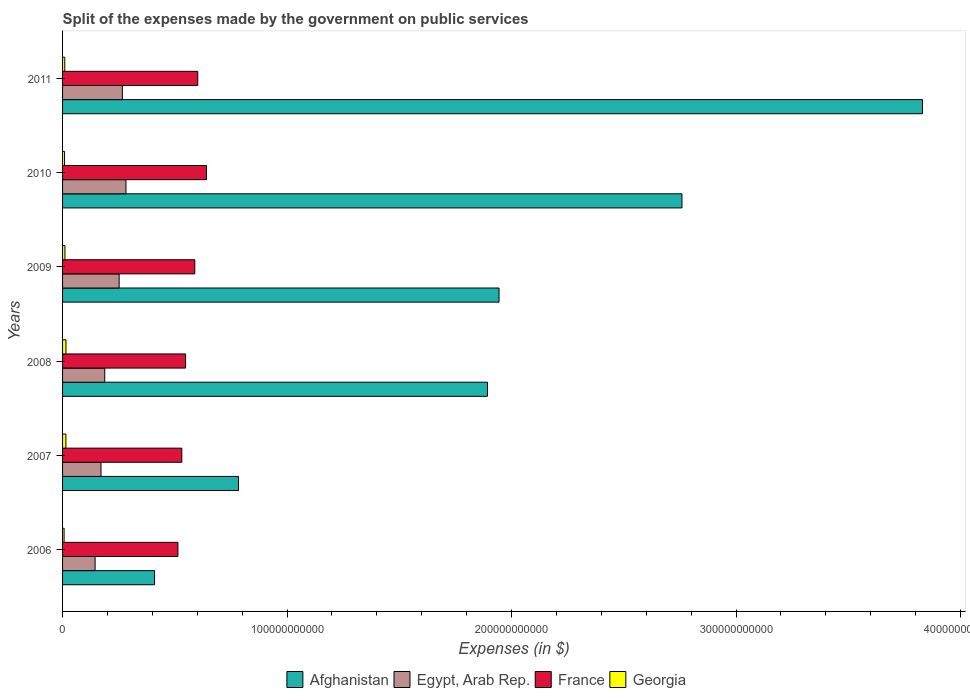What is the expenses made by the government on public services in Egypt, Arab Rep. in 2009?
Make the answer very short. 2.52e+1. Across all years, what is the maximum expenses made by the government on public services in Afghanistan?
Make the answer very short. 3.83e+11. Across all years, what is the minimum expenses made by the government on public services in France?
Make the answer very short. 5.14e+1. In which year was the expenses made by the government on public services in Egypt, Arab Rep. maximum?
Ensure brevity in your answer.  2010. In which year was the expenses made by the government on public services in Afghanistan minimum?
Offer a terse response. 2006. What is the total expenses made by the government on public services in Afghanistan in the graph?
Make the answer very short. 1.16e+12. What is the difference between the expenses made by the government on public services in Afghanistan in 2007 and that in 2011?
Your answer should be very brief. -3.05e+11. What is the difference between the expenses made by the government on public services in Afghanistan in 2010 and the expenses made by the government on public services in Georgia in 2009?
Ensure brevity in your answer.  2.75e+11. What is the average expenses made by the government on public services in Egypt, Arab Rep. per year?
Provide a succinct answer. 2.17e+1. In the year 2011, what is the difference between the expenses made by the government on public services in Afghanistan and expenses made by the government on public services in France?
Give a very brief answer. 3.23e+11. In how many years, is the expenses made by the government on public services in Afghanistan greater than 300000000000 $?
Provide a short and direct response. 1. What is the ratio of the expenses made by the government on public services in Egypt, Arab Rep. in 2009 to that in 2011?
Give a very brief answer. 0.95. Is the difference between the expenses made by the government on public services in Afghanistan in 2007 and 2010 greater than the difference between the expenses made by the government on public services in France in 2007 and 2010?
Offer a terse response. No. What is the difference between the highest and the second highest expenses made by the government on public services in Georgia?
Provide a short and direct response. 2.49e+07. What is the difference between the highest and the lowest expenses made by the government on public services in Georgia?
Keep it short and to the point. 8.30e+08. Is the sum of the expenses made by the government on public services in Egypt, Arab Rep. in 2007 and 2011 greater than the maximum expenses made by the government on public services in France across all years?
Ensure brevity in your answer.  No. Is it the case that in every year, the sum of the expenses made by the government on public services in Georgia and expenses made by the government on public services in France is greater than the sum of expenses made by the government on public services in Afghanistan and expenses made by the government on public services in Egypt, Arab Rep.?
Give a very brief answer. No. What does the 3rd bar from the top in 2009 represents?
Keep it short and to the point. Egypt, Arab Rep. What does the 1st bar from the bottom in 2007 represents?
Keep it short and to the point. Afghanistan. Is it the case that in every year, the sum of the expenses made by the government on public services in Georgia and expenses made by the government on public services in France is greater than the expenses made by the government on public services in Egypt, Arab Rep.?
Your response must be concise. Yes. How many bars are there?
Keep it short and to the point. 24. Are all the bars in the graph horizontal?
Keep it short and to the point. Yes. What is the difference between two consecutive major ticks on the X-axis?
Provide a succinct answer. 1.00e+11. Are the values on the major ticks of X-axis written in scientific E-notation?
Your answer should be very brief. No. Does the graph contain grids?
Provide a short and direct response. No. Where does the legend appear in the graph?
Provide a succinct answer. Bottom center. How many legend labels are there?
Provide a succinct answer. 4. How are the legend labels stacked?
Give a very brief answer. Horizontal. What is the title of the graph?
Offer a terse response. Split of the expenses made by the government on public services. Does "Yemen, Rep." appear as one of the legend labels in the graph?
Offer a terse response. No. What is the label or title of the X-axis?
Offer a very short reply. Expenses (in $). What is the Expenses (in $) of Afghanistan in 2006?
Provide a succinct answer. 4.10e+1. What is the Expenses (in $) of Egypt, Arab Rep. in 2006?
Ensure brevity in your answer.  1.45e+1. What is the Expenses (in $) of France in 2006?
Keep it short and to the point. 5.14e+1. What is the Expenses (in $) of Georgia in 2006?
Give a very brief answer. 6.78e+08. What is the Expenses (in $) in Afghanistan in 2007?
Make the answer very short. 7.84e+1. What is the Expenses (in $) in Egypt, Arab Rep. in 2007?
Your response must be concise. 1.71e+1. What is the Expenses (in $) in France in 2007?
Provide a succinct answer. 5.31e+1. What is the Expenses (in $) of Georgia in 2007?
Keep it short and to the point. 1.48e+09. What is the Expenses (in $) in Afghanistan in 2008?
Give a very brief answer. 1.89e+11. What is the Expenses (in $) of Egypt, Arab Rep. in 2008?
Provide a short and direct response. 1.88e+1. What is the Expenses (in $) in France in 2008?
Make the answer very short. 5.48e+1. What is the Expenses (in $) of Georgia in 2008?
Give a very brief answer. 1.51e+09. What is the Expenses (in $) of Afghanistan in 2009?
Offer a terse response. 1.94e+11. What is the Expenses (in $) of Egypt, Arab Rep. in 2009?
Your answer should be very brief. 2.52e+1. What is the Expenses (in $) in France in 2009?
Provide a succinct answer. 5.89e+1. What is the Expenses (in $) in Georgia in 2009?
Make the answer very short. 1.06e+09. What is the Expenses (in $) in Afghanistan in 2010?
Give a very brief answer. 2.76e+11. What is the Expenses (in $) of Egypt, Arab Rep. in 2010?
Make the answer very short. 2.82e+1. What is the Expenses (in $) in France in 2010?
Offer a very short reply. 6.41e+1. What is the Expenses (in $) of Georgia in 2010?
Your response must be concise. 8.82e+08. What is the Expenses (in $) of Afghanistan in 2011?
Your response must be concise. 3.83e+11. What is the Expenses (in $) of Egypt, Arab Rep. in 2011?
Your answer should be compact. 2.66e+1. What is the Expenses (in $) in France in 2011?
Keep it short and to the point. 6.02e+1. What is the Expenses (in $) in Georgia in 2011?
Provide a succinct answer. 9.89e+08. Across all years, what is the maximum Expenses (in $) of Afghanistan?
Your response must be concise. 3.83e+11. Across all years, what is the maximum Expenses (in $) in Egypt, Arab Rep.?
Your answer should be compact. 2.82e+1. Across all years, what is the maximum Expenses (in $) of France?
Provide a succinct answer. 6.41e+1. Across all years, what is the maximum Expenses (in $) of Georgia?
Provide a succinct answer. 1.51e+09. Across all years, what is the minimum Expenses (in $) of Afghanistan?
Provide a short and direct response. 4.10e+1. Across all years, what is the minimum Expenses (in $) of Egypt, Arab Rep.?
Your answer should be compact. 1.45e+1. Across all years, what is the minimum Expenses (in $) in France?
Your answer should be very brief. 5.14e+1. Across all years, what is the minimum Expenses (in $) in Georgia?
Your response must be concise. 6.78e+08. What is the total Expenses (in $) of Afghanistan in the graph?
Keep it short and to the point. 1.16e+12. What is the total Expenses (in $) in Egypt, Arab Rep. in the graph?
Your response must be concise. 1.30e+11. What is the total Expenses (in $) of France in the graph?
Keep it short and to the point. 3.43e+11. What is the total Expenses (in $) of Georgia in the graph?
Your answer should be compact. 6.60e+09. What is the difference between the Expenses (in $) of Afghanistan in 2006 and that in 2007?
Give a very brief answer. -3.74e+1. What is the difference between the Expenses (in $) of Egypt, Arab Rep. in 2006 and that in 2007?
Make the answer very short. -2.63e+09. What is the difference between the Expenses (in $) in France in 2006 and that in 2007?
Provide a short and direct response. -1.73e+09. What is the difference between the Expenses (in $) of Georgia in 2006 and that in 2007?
Offer a terse response. -8.05e+08. What is the difference between the Expenses (in $) of Afghanistan in 2006 and that in 2008?
Your answer should be compact. -1.48e+11. What is the difference between the Expenses (in $) in Egypt, Arab Rep. in 2006 and that in 2008?
Offer a very short reply. -4.30e+09. What is the difference between the Expenses (in $) in France in 2006 and that in 2008?
Offer a terse response. -3.41e+09. What is the difference between the Expenses (in $) in Georgia in 2006 and that in 2008?
Ensure brevity in your answer.  -8.30e+08. What is the difference between the Expenses (in $) of Afghanistan in 2006 and that in 2009?
Provide a short and direct response. -1.53e+11. What is the difference between the Expenses (in $) in Egypt, Arab Rep. in 2006 and that in 2009?
Provide a succinct answer. -1.07e+1. What is the difference between the Expenses (in $) of France in 2006 and that in 2009?
Offer a very short reply. -7.52e+09. What is the difference between the Expenses (in $) in Georgia in 2006 and that in 2009?
Provide a short and direct response. -3.77e+08. What is the difference between the Expenses (in $) of Afghanistan in 2006 and that in 2010?
Your response must be concise. -2.35e+11. What is the difference between the Expenses (in $) of Egypt, Arab Rep. in 2006 and that in 2010?
Provide a short and direct response. -1.38e+1. What is the difference between the Expenses (in $) of France in 2006 and that in 2010?
Offer a terse response. -1.27e+1. What is the difference between the Expenses (in $) in Georgia in 2006 and that in 2010?
Offer a terse response. -2.03e+08. What is the difference between the Expenses (in $) of Afghanistan in 2006 and that in 2011?
Provide a succinct answer. -3.42e+11. What is the difference between the Expenses (in $) in Egypt, Arab Rep. in 2006 and that in 2011?
Ensure brevity in your answer.  -1.22e+1. What is the difference between the Expenses (in $) in France in 2006 and that in 2011?
Your answer should be compact. -8.83e+09. What is the difference between the Expenses (in $) of Georgia in 2006 and that in 2011?
Offer a very short reply. -3.10e+08. What is the difference between the Expenses (in $) of Afghanistan in 2007 and that in 2008?
Your answer should be very brief. -1.11e+11. What is the difference between the Expenses (in $) in Egypt, Arab Rep. in 2007 and that in 2008?
Keep it short and to the point. -1.67e+09. What is the difference between the Expenses (in $) in France in 2007 and that in 2008?
Ensure brevity in your answer.  -1.68e+09. What is the difference between the Expenses (in $) of Georgia in 2007 and that in 2008?
Ensure brevity in your answer.  -2.49e+07. What is the difference between the Expenses (in $) of Afghanistan in 2007 and that in 2009?
Keep it short and to the point. -1.16e+11. What is the difference between the Expenses (in $) in Egypt, Arab Rep. in 2007 and that in 2009?
Make the answer very short. -8.08e+09. What is the difference between the Expenses (in $) in France in 2007 and that in 2009?
Make the answer very short. -5.79e+09. What is the difference between the Expenses (in $) of Georgia in 2007 and that in 2009?
Offer a terse response. 4.29e+08. What is the difference between the Expenses (in $) of Afghanistan in 2007 and that in 2010?
Make the answer very short. -1.98e+11. What is the difference between the Expenses (in $) of Egypt, Arab Rep. in 2007 and that in 2010?
Your answer should be very brief. -1.11e+1. What is the difference between the Expenses (in $) in France in 2007 and that in 2010?
Ensure brevity in your answer.  -1.10e+1. What is the difference between the Expenses (in $) of Georgia in 2007 and that in 2010?
Offer a very short reply. 6.02e+08. What is the difference between the Expenses (in $) in Afghanistan in 2007 and that in 2011?
Ensure brevity in your answer.  -3.05e+11. What is the difference between the Expenses (in $) in Egypt, Arab Rep. in 2007 and that in 2011?
Offer a very short reply. -9.52e+09. What is the difference between the Expenses (in $) of France in 2007 and that in 2011?
Provide a succinct answer. -7.10e+09. What is the difference between the Expenses (in $) of Georgia in 2007 and that in 2011?
Your response must be concise. 4.95e+08. What is the difference between the Expenses (in $) of Afghanistan in 2008 and that in 2009?
Provide a short and direct response. -5.15e+09. What is the difference between the Expenses (in $) of Egypt, Arab Rep. in 2008 and that in 2009?
Make the answer very short. -6.41e+09. What is the difference between the Expenses (in $) in France in 2008 and that in 2009?
Keep it short and to the point. -4.11e+09. What is the difference between the Expenses (in $) in Georgia in 2008 and that in 2009?
Provide a short and direct response. 4.54e+08. What is the difference between the Expenses (in $) of Afghanistan in 2008 and that in 2010?
Give a very brief answer. -8.66e+1. What is the difference between the Expenses (in $) in Egypt, Arab Rep. in 2008 and that in 2010?
Ensure brevity in your answer.  -9.46e+09. What is the difference between the Expenses (in $) in France in 2008 and that in 2010?
Offer a very short reply. -9.30e+09. What is the difference between the Expenses (in $) in Georgia in 2008 and that in 2010?
Ensure brevity in your answer.  6.27e+08. What is the difference between the Expenses (in $) of Afghanistan in 2008 and that in 2011?
Give a very brief answer. -1.94e+11. What is the difference between the Expenses (in $) in Egypt, Arab Rep. in 2008 and that in 2011?
Offer a very short reply. -7.86e+09. What is the difference between the Expenses (in $) in France in 2008 and that in 2011?
Your answer should be compact. -5.42e+09. What is the difference between the Expenses (in $) of Georgia in 2008 and that in 2011?
Keep it short and to the point. 5.20e+08. What is the difference between the Expenses (in $) in Afghanistan in 2009 and that in 2010?
Offer a very short reply. -8.15e+1. What is the difference between the Expenses (in $) of Egypt, Arab Rep. in 2009 and that in 2010?
Provide a succinct answer. -3.04e+09. What is the difference between the Expenses (in $) in France in 2009 and that in 2010?
Provide a short and direct response. -5.20e+09. What is the difference between the Expenses (in $) in Georgia in 2009 and that in 2010?
Your response must be concise. 1.74e+08. What is the difference between the Expenses (in $) in Afghanistan in 2009 and that in 2011?
Your response must be concise. -1.89e+11. What is the difference between the Expenses (in $) in Egypt, Arab Rep. in 2009 and that in 2011?
Give a very brief answer. -1.44e+09. What is the difference between the Expenses (in $) in France in 2009 and that in 2011?
Keep it short and to the point. -1.31e+09. What is the difference between the Expenses (in $) of Georgia in 2009 and that in 2011?
Provide a short and direct response. 6.62e+07. What is the difference between the Expenses (in $) in Afghanistan in 2010 and that in 2011?
Offer a terse response. -1.07e+11. What is the difference between the Expenses (in $) in Egypt, Arab Rep. in 2010 and that in 2011?
Make the answer very short. 1.60e+09. What is the difference between the Expenses (in $) of France in 2010 and that in 2011?
Give a very brief answer. 3.88e+09. What is the difference between the Expenses (in $) of Georgia in 2010 and that in 2011?
Offer a very short reply. -1.07e+08. What is the difference between the Expenses (in $) in Afghanistan in 2006 and the Expenses (in $) in Egypt, Arab Rep. in 2007?
Your answer should be very brief. 2.39e+1. What is the difference between the Expenses (in $) of Afghanistan in 2006 and the Expenses (in $) of France in 2007?
Offer a very short reply. -1.21e+1. What is the difference between the Expenses (in $) in Afghanistan in 2006 and the Expenses (in $) in Georgia in 2007?
Offer a terse response. 3.95e+1. What is the difference between the Expenses (in $) of Egypt, Arab Rep. in 2006 and the Expenses (in $) of France in 2007?
Make the answer very short. -3.86e+1. What is the difference between the Expenses (in $) of Egypt, Arab Rep. in 2006 and the Expenses (in $) of Georgia in 2007?
Ensure brevity in your answer.  1.30e+1. What is the difference between the Expenses (in $) in France in 2006 and the Expenses (in $) in Georgia in 2007?
Your response must be concise. 4.99e+1. What is the difference between the Expenses (in $) of Afghanistan in 2006 and the Expenses (in $) of Egypt, Arab Rep. in 2008?
Provide a short and direct response. 2.22e+1. What is the difference between the Expenses (in $) in Afghanistan in 2006 and the Expenses (in $) in France in 2008?
Make the answer very short. -1.38e+1. What is the difference between the Expenses (in $) in Afghanistan in 2006 and the Expenses (in $) in Georgia in 2008?
Ensure brevity in your answer.  3.95e+1. What is the difference between the Expenses (in $) in Egypt, Arab Rep. in 2006 and the Expenses (in $) in France in 2008?
Offer a terse response. -4.03e+1. What is the difference between the Expenses (in $) of Egypt, Arab Rep. in 2006 and the Expenses (in $) of Georgia in 2008?
Keep it short and to the point. 1.30e+1. What is the difference between the Expenses (in $) in France in 2006 and the Expenses (in $) in Georgia in 2008?
Your answer should be compact. 4.99e+1. What is the difference between the Expenses (in $) in Afghanistan in 2006 and the Expenses (in $) in Egypt, Arab Rep. in 2009?
Give a very brief answer. 1.58e+1. What is the difference between the Expenses (in $) of Afghanistan in 2006 and the Expenses (in $) of France in 2009?
Give a very brief answer. -1.79e+1. What is the difference between the Expenses (in $) in Afghanistan in 2006 and the Expenses (in $) in Georgia in 2009?
Provide a succinct answer. 3.99e+1. What is the difference between the Expenses (in $) of Egypt, Arab Rep. in 2006 and the Expenses (in $) of France in 2009?
Ensure brevity in your answer.  -4.44e+1. What is the difference between the Expenses (in $) in Egypt, Arab Rep. in 2006 and the Expenses (in $) in Georgia in 2009?
Your answer should be compact. 1.34e+1. What is the difference between the Expenses (in $) in France in 2006 and the Expenses (in $) in Georgia in 2009?
Provide a short and direct response. 5.03e+1. What is the difference between the Expenses (in $) in Afghanistan in 2006 and the Expenses (in $) in Egypt, Arab Rep. in 2010?
Keep it short and to the point. 1.27e+1. What is the difference between the Expenses (in $) of Afghanistan in 2006 and the Expenses (in $) of France in 2010?
Ensure brevity in your answer.  -2.31e+1. What is the difference between the Expenses (in $) in Afghanistan in 2006 and the Expenses (in $) in Georgia in 2010?
Make the answer very short. 4.01e+1. What is the difference between the Expenses (in $) of Egypt, Arab Rep. in 2006 and the Expenses (in $) of France in 2010?
Offer a very short reply. -4.96e+1. What is the difference between the Expenses (in $) of Egypt, Arab Rep. in 2006 and the Expenses (in $) of Georgia in 2010?
Offer a very short reply. 1.36e+1. What is the difference between the Expenses (in $) in France in 2006 and the Expenses (in $) in Georgia in 2010?
Give a very brief answer. 5.05e+1. What is the difference between the Expenses (in $) in Afghanistan in 2006 and the Expenses (in $) in Egypt, Arab Rep. in 2011?
Keep it short and to the point. 1.43e+1. What is the difference between the Expenses (in $) in Afghanistan in 2006 and the Expenses (in $) in France in 2011?
Provide a short and direct response. -1.92e+1. What is the difference between the Expenses (in $) in Afghanistan in 2006 and the Expenses (in $) in Georgia in 2011?
Provide a succinct answer. 4.00e+1. What is the difference between the Expenses (in $) in Egypt, Arab Rep. in 2006 and the Expenses (in $) in France in 2011?
Ensure brevity in your answer.  -4.57e+1. What is the difference between the Expenses (in $) of Egypt, Arab Rep. in 2006 and the Expenses (in $) of Georgia in 2011?
Your answer should be compact. 1.35e+1. What is the difference between the Expenses (in $) in France in 2006 and the Expenses (in $) in Georgia in 2011?
Provide a short and direct response. 5.04e+1. What is the difference between the Expenses (in $) of Afghanistan in 2007 and the Expenses (in $) of Egypt, Arab Rep. in 2008?
Make the answer very short. 5.96e+1. What is the difference between the Expenses (in $) in Afghanistan in 2007 and the Expenses (in $) in France in 2008?
Make the answer very short. 2.36e+1. What is the difference between the Expenses (in $) of Afghanistan in 2007 and the Expenses (in $) of Georgia in 2008?
Your answer should be very brief. 7.69e+1. What is the difference between the Expenses (in $) of Egypt, Arab Rep. in 2007 and the Expenses (in $) of France in 2008?
Your answer should be very brief. -3.77e+1. What is the difference between the Expenses (in $) in Egypt, Arab Rep. in 2007 and the Expenses (in $) in Georgia in 2008?
Ensure brevity in your answer.  1.56e+1. What is the difference between the Expenses (in $) of France in 2007 and the Expenses (in $) of Georgia in 2008?
Keep it short and to the point. 5.16e+1. What is the difference between the Expenses (in $) in Afghanistan in 2007 and the Expenses (in $) in Egypt, Arab Rep. in 2009?
Your answer should be very brief. 5.32e+1. What is the difference between the Expenses (in $) of Afghanistan in 2007 and the Expenses (in $) of France in 2009?
Offer a terse response. 1.95e+1. What is the difference between the Expenses (in $) in Afghanistan in 2007 and the Expenses (in $) in Georgia in 2009?
Make the answer very short. 7.73e+1. What is the difference between the Expenses (in $) of Egypt, Arab Rep. in 2007 and the Expenses (in $) of France in 2009?
Make the answer very short. -4.18e+1. What is the difference between the Expenses (in $) of Egypt, Arab Rep. in 2007 and the Expenses (in $) of Georgia in 2009?
Provide a short and direct response. 1.61e+1. What is the difference between the Expenses (in $) of France in 2007 and the Expenses (in $) of Georgia in 2009?
Ensure brevity in your answer.  5.21e+1. What is the difference between the Expenses (in $) of Afghanistan in 2007 and the Expenses (in $) of Egypt, Arab Rep. in 2010?
Offer a terse response. 5.01e+1. What is the difference between the Expenses (in $) in Afghanistan in 2007 and the Expenses (in $) in France in 2010?
Provide a short and direct response. 1.43e+1. What is the difference between the Expenses (in $) in Afghanistan in 2007 and the Expenses (in $) in Georgia in 2010?
Provide a succinct answer. 7.75e+1. What is the difference between the Expenses (in $) in Egypt, Arab Rep. in 2007 and the Expenses (in $) in France in 2010?
Give a very brief answer. -4.70e+1. What is the difference between the Expenses (in $) of Egypt, Arab Rep. in 2007 and the Expenses (in $) of Georgia in 2010?
Offer a terse response. 1.62e+1. What is the difference between the Expenses (in $) of France in 2007 and the Expenses (in $) of Georgia in 2010?
Your response must be concise. 5.22e+1. What is the difference between the Expenses (in $) in Afghanistan in 2007 and the Expenses (in $) in Egypt, Arab Rep. in 2011?
Your response must be concise. 5.17e+1. What is the difference between the Expenses (in $) of Afghanistan in 2007 and the Expenses (in $) of France in 2011?
Your answer should be compact. 1.81e+1. What is the difference between the Expenses (in $) of Afghanistan in 2007 and the Expenses (in $) of Georgia in 2011?
Your answer should be compact. 7.74e+1. What is the difference between the Expenses (in $) of Egypt, Arab Rep. in 2007 and the Expenses (in $) of France in 2011?
Your answer should be very brief. -4.31e+1. What is the difference between the Expenses (in $) of Egypt, Arab Rep. in 2007 and the Expenses (in $) of Georgia in 2011?
Give a very brief answer. 1.61e+1. What is the difference between the Expenses (in $) in France in 2007 and the Expenses (in $) in Georgia in 2011?
Your response must be concise. 5.21e+1. What is the difference between the Expenses (in $) in Afghanistan in 2008 and the Expenses (in $) in Egypt, Arab Rep. in 2009?
Offer a terse response. 1.64e+11. What is the difference between the Expenses (in $) of Afghanistan in 2008 and the Expenses (in $) of France in 2009?
Ensure brevity in your answer.  1.30e+11. What is the difference between the Expenses (in $) of Afghanistan in 2008 and the Expenses (in $) of Georgia in 2009?
Your response must be concise. 1.88e+11. What is the difference between the Expenses (in $) in Egypt, Arab Rep. in 2008 and the Expenses (in $) in France in 2009?
Offer a very short reply. -4.01e+1. What is the difference between the Expenses (in $) of Egypt, Arab Rep. in 2008 and the Expenses (in $) of Georgia in 2009?
Keep it short and to the point. 1.77e+1. What is the difference between the Expenses (in $) in France in 2008 and the Expenses (in $) in Georgia in 2009?
Provide a succinct answer. 5.37e+1. What is the difference between the Expenses (in $) in Afghanistan in 2008 and the Expenses (in $) in Egypt, Arab Rep. in 2010?
Make the answer very short. 1.61e+11. What is the difference between the Expenses (in $) in Afghanistan in 2008 and the Expenses (in $) in France in 2010?
Offer a terse response. 1.25e+11. What is the difference between the Expenses (in $) of Afghanistan in 2008 and the Expenses (in $) of Georgia in 2010?
Offer a terse response. 1.88e+11. What is the difference between the Expenses (in $) of Egypt, Arab Rep. in 2008 and the Expenses (in $) of France in 2010?
Your response must be concise. -4.53e+1. What is the difference between the Expenses (in $) of Egypt, Arab Rep. in 2008 and the Expenses (in $) of Georgia in 2010?
Keep it short and to the point. 1.79e+1. What is the difference between the Expenses (in $) of France in 2008 and the Expenses (in $) of Georgia in 2010?
Offer a terse response. 5.39e+1. What is the difference between the Expenses (in $) in Afghanistan in 2008 and the Expenses (in $) in Egypt, Arab Rep. in 2011?
Provide a short and direct response. 1.63e+11. What is the difference between the Expenses (in $) in Afghanistan in 2008 and the Expenses (in $) in France in 2011?
Your response must be concise. 1.29e+11. What is the difference between the Expenses (in $) in Afghanistan in 2008 and the Expenses (in $) in Georgia in 2011?
Make the answer very short. 1.88e+11. What is the difference between the Expenses (in $) in Egypt, Arab Rep. in 2008 and the Expenses (in $) in France in 2011?
Provide a succinct answer. -4.14e+1. What is the difference between the Expenses (in $) of Egypt, Arab Rep. in 2008 and the Expenses (in $) of Georgia in 2011?
Offer a very short reply. 1.78e+1. What is the difference between the Expenses (in $) of France in 2008 and the Expenses (in $) of Georgia in 2011?
Offer a terse response. 5.38e+1. What is the difference between the Expenses (in $) of Afghanistan in 2009 and the Expenses (in $) of Egypt, Arab Rep. in 2010?
Ensure brevity in your answer.  1.66e+11. What is the difference between the Expenses (in $) of Afghanistan in 2009 and the Expenses (in $) of France in 2010?
Keep it short and to the point. 1.30e+11. What is the difference between the Expenses (in $) of Afghanistan in 2009 and the Expenses (in $) of Georgia in 2010?
Offer a very short reply. 1.94e+11. What is the difference between the Expenses (in $) of Egypt, Arab Rep. in 2009 and the Expenses (in $) of France in 2010?
Your answer should be very brief. -3.89e+1. What is the difference between the Expenses (in $) of Egypt, Arab Rep. in 2009 and the Expenses (in $) of Georgia in 2010?
Your response must be concise. 2.43e+1. What is the difference between the Expenses (in $) of France in 2009 and the Expenses (in $) of Georgia in 2010?
Your response must be concise. 5.80e+1. What is the difference between the Expenses (in $) in Afghanistan in 2009 and the Expenses (in $) in Egypt, Arab Rep. in 2011?
Ensure brevity in your answer.  1.68e+11. What is the difference between the Expenses (in $) in Afghanistan in 2009 and the Expenses (in $) in France in 2011?
Keep it short and to the point. 1.34e+11. What is the difference between the Expenses (in $) of Afghanistan in 2009 and the Expenses (in $) of Georgia in 2011?
Provide a succinct answer. 1.93e+11. What is the difference between the Expenses (in $) in Egypt, Arab Rep. in 2009 and the Expenses (in $) in France in 2011?
Your response must be concise. -3.50e+1. What is the difference between the Expenses (in $) in Egypt, Arab Rep. in 2009 and the Expenses (in $) in Georgia in 2011?
Your answer should be compact. 2.42e+1. What is the difference between the Expenses (in $) in France in 2009 and the Expenses (in $) in Georgia in 2011?
Provide a succinct answer. 5.79e+1. What is the difference between the Expenses (in $) of Afghanistan in 2010 and the Expenses (in $) of Egypt, Arab Rep. in 2011?
Provide a succinct answer. 2.49e+11. What is the difference between the Expenses (in $) of Afghanistan in 2010 and the Expenses (in $) of France in 2011?
Your answer should be compact. 2.16e+11. What is the difference between the Expenses (in $) in Afghanistan in 2010 and the Expenses (in $) in Georgia in 2011?
Your response must be concise. 2.75e+11. What is the difference between the Expenses (in $) in Egypt, Arab Rep. in 2010 and the Expenses (in $) in France in 2011?
Offer a very short reply. -3.20e+1. What is the difference between the Expenses (in $) of Egypt, Arab Rep. in 2010 and the Expenses (in $) of Georgia in 2011?
Give a very brief answer. 2.73e+1. What is the difference between the Expenses (in $) in France in 2010 and the Expenses (in $) in Georgia in 2011?
Offer a very short reply. 6.31e+1. What is the average Expenses (in $) in Afghanistan per year?
Your response must be concise. 1.94e+11. What is the average Expenses (in $) of Egypt, Arab Rep. per year?
Keep it short and to the point. 2.17e+1. What is the average Expenses (in $) of France per year?
Your answer should be compact. 5.71e+1. What is the average Expenses (in $) of Georgia per year?
Ensure brevity in your answer.  1.10e+09. In the year 2006, what is the difference between the Expenses (in $) of Afghanistan and Expenses (in $) of Egypt, Arab Rep.?
Your answer should be very brief. 2.65e+1. In the year 2006, what is the difference between the Expenses (in $) of Afghanistan and Expenses (in $) of France?
Give a very brief answer. -1.04e+1. In the year 2006, what is the difference between the Expenses (in $) of Afghanistan and Expenses (in $) of Georgia?
Provide a short and direct response. 4.03e+1. In the year 2006, what is the difference between the Expenses (in $) in Egypt, Arab Rep. and Expenses (in $) in France?
Give a very brief answer. -3.69e+1. In the year 2006, what is the difference between the Expenses (in $) of Egypt, Arab Rep. and Expenses (in $) of Georgia?
Your answer should be very brief. 1.38e+1. In the year 2006, what is the difference between the Expenses (in $) of France and Expenses (in $) of Georgia?
Your response must be concise. 5.07e+1. In the year 2007, what is the difference between the Expenses (in $) in Afghanistan and Expenses (in $) in Egypt, Arab Rep.?
Your answer should be very brief. 6.12e+1. In the year 2007, what is the difference between the Expenses (in $) in Afghanistan and Expenses (in $) in France?
Keep it short and to the point. 2.52e+1. In the year 2007, what is the difference between the Expenses (in $) of Afghanistan and Expenses (in $) of Georgia?
Make the answer very short. 7.69e+1. In the year 2007, what is the difference between the Expenses (in $) of Egypt, Arab Rep. and Expenses (in $) of France?
Give a very brief answer. -3.60e+1. In the year 2007, what is the difference between the Expenses (in $) of Egypt, Arab Rep. and Expenses (in $) of Georgia?
Offer a very short reply. 1.56e+1. In the year 2007, what is the difference between the Expenses (in $) in France and Expenses (in $) in Georgia?
Make the answer very short. 5.16e+1. In the year 2008, what is the difference between the Expenses (in $) of Afghanistan and Expenses (in $) of Egypt, Arab Rep.?
Give a very brief answer. 1.70e+11. In the year 2008, what is the difference between the Expenses (in $) in Afghanistan and Expenses (in $) in France?
Offer a terse response. 1.34e+11. In the year 2008, what is the difference between the Expenses (in $) of Afghanistan and Expenses (in $) of Georgia?
Offer a very short reply. 1.88e+11. In the year 2008, what is the difference between the Expenses (in $) in Egypt, Arab Rep. and Expenses (in $) in France?
Give a very brief answer. -3.60e+1. In the year 2008, what is the difference between the Expenses (in $) in Egypt, Arab Rep. and Expenses (in $) in Georgia?
Your answer should be compact. 1.73e+1. In the year 2008, what is the difference between the Expenses (in $) in France and Expenses (in $) in Georgia?
Offer a terse response. 5.33e+1. In the year 2009, what is the difference between the Expenses (in $) in Afghanistan and Expenses (in $) in Egypt, Arab Rep.?
Provide a short and direct response. 1.69e+11. In the year 2009, what is the difference between the Expenses (in $) in Afghanistan and Expenses (in $) in France?
Offer a very short reply. 1.36e+11. In the year 2009, what is the difference between the Expenses (in $) of Afghanistan and Expenses (in $) of Georgia?
Your response must be concise. 1.93e+11. In the year 2009, what is the difference between the Expenses (in $) in Egypt, Arab Rep. and Expenses (in $) in France?
Ensure brevity in your answer.  -3.37e+1. In the year 2009, what is the difference between the Expenses (in $) of Egypt, Arab Rep. and Expenses (in $) of Georgia?
Ensure brevity in your answer.  2.41e+1. In the year 2009, what is the difference between the Expenses (in $) of France and Expenses (in $) of Georgia?
Your answer should be compact. 5.79e+1. In the year 2010, what is the difference between the Expenses (in $) in Afghanistan and Expenses (in $) in Egypt, Arab Rep.?
Provide a short and direct response. 2.48e+11. In the year 2010, what is the difference between the Expenses (in $) in Afghanistan and Expenses (in $) in France?
Your answer should be compact. 2.12e+11. In the year 2010, what is the difference between the Expenses (in $) in Afghanistan and Expenses (in $) in Georgia?
Your answer should be very brief. 2.75e+11. In the year 2010, what is the difference between the Expenses (in $) of Egypt, Arab Rep. and Expenses (in $) of France?
Make the answer very short. -3.59e+1. In the year 2010, what is the difference between the Expenses (in $) in Egypt, Arab Rep. and Expenses (in $) in Georgia?
Ensure brevity in your answer.  2.74e+1. In the year 2010, what is the difference between the Expenses (in $) in France and Expenses (in $) in Georgia?
Your response must be concise. 6.32e+1. In the year 2011, what is the difference between the Expenses (in $) of Afghanistan and Expenses (in $) of Egypt, Arab Rep.?
Provide a short and direct response. 3.56e+11. In the year 2011, what is the difference between the Expenses (in $) of Afghanistan and Expenses (in $) of France?
Offer a terse response. 3.23e+11. In the year 2011, what is the difference between the Expenses (in $) of Afghanistan and Expenses (in $) of Georgia?
Your answer should be compact. 3.82e+11. In the year 2011, what is the difference between the Expenses (in $) in Egypt, Arab Rep. and Expenses (in $) in France?
Ensure brevity in your answer.  -3.36e+1. In the year 2011, what is the difference between the Expenses (in $) in Egypt, Arab Rep. and Expenses (in $) in Georgia?
Keep it short and to the point. 2.57e+1. In the year 2011, what is the difference between the Expenses (in $) in France and Expenses (in $) in Georgia?
Make the answer very short. 5.92e+1. What is the ratio of the Expenses (in $) of Afghanistan in 2006 to that in 2007?
Provide a short and direct response. 0.52. What is the ratio of the Expenses (in $) of Egypt, Arab Rep. in 2006 to that in 2007?
Ensure brevity in your answer.  0.85. What is the ratio of the Expenses (in $) of France in 2006 to that in 2007?
Provide a short and direct response. 0.97. What is the ratio of the Expenses (in $) in Georgia in 2006 to that in 2007?
Ensure brevity in your answer.  0.46. What is the ratio of the Expenses (in $) of Afghanistan in 2006 to that in 2008?
Keep it short and to the point. 0.22. What is the ratio of the Expenses (in $) of Egypt, Arab Rep. in 2006 to that in 2008?
Keep it short and to the point. 0.77. What is the ratio of the Expenses (in $) in France in 2006 to that in 2008?
Ensure brevity in your answer.  0.94. What is the ratio of the Expenses (in $) in Georgia in 2006 to that in 2008?
Keep it short and to the point. 0.45. What is the ratio of the Expenses (in $) in Afghanistan in 2006 to that in 2009?
Offer a very short reply. 0.21. What is the ratio of the Expenses (in $) in Egypt, Arab Rep. in 2006 to that in 2009?
Offer a very short reply. 0.58. What is the ratio of the Expenses (in $) of France in 2006 to that in 2009?
Keep it short and to the point. 0.87. What is the ratio of the Expenses (in $) in Georgia in 2006 to that in 2009?
Ensure brevity in your answer.  0.64. What is the ratio of the Expenses (in $) of Afghanistan in 2006 to that in 2010?
Offer a very short reply. 0.15. What is the ratio of the Expenses (in $) of Egypt, Arab Rep. in 2006 to that in 2010?
Offer a very short reply. 0.51. What is the ratio of the Expenses (in $) of France in 2006 to that in 2010?
Provide a succinct answer. 0.8. What is the ratio of the Expenses (in $) in Georgia in 2006 to that in 2010?
Provide a succinct answer. 0.77. What is the ratio of the Expenses (in $) in Afghanistan in 2006 to that in 2011?
Offer a terse response. 0.11. What is the ratio of the Expenses (in $) in Egypt, Arab Rep. in 2006 to that in 2011?
Keep it short and to the point. 0.54. What is the ratio of the Expenses (in $) of France in 2006 to that in 2011?
Your answer should be compact. 0.85. What is the ratio of the Expenses (in $) in Georgia in 2006 to that in 2011?
Offer a terse response. 0.69. What is the ratio of the Expenses (in $) in Afghanistan in 2007 to that in 2008?
Your answer should be compact. 0.41. What is the ratio of the Expenses (in $) in Egypt, Arab Rep. in 2007 to that in 2008?
Offer a very short reply. 0.91. What is the ratio of the Expenses (in $) in France in 2007 to that in 2008?
Provide a succinct answer. 0.97. What is the ratio of the Expenses (in $) in Georgia in 2007 to that in 2008?
Your answer should be very brief. 0.98. What is the ratio of the Expenses (in $) in Afghanistan in 2007 to that in 2009?
Ensure brevity in your answer.  0.4. What is the ratio of the Expenses (in $) in Egypt, Arab Rep. in 2007 to that in 2009?
Keep it short and to the point. 0.68. What is the ratio of the Expenses (in $) in France in 2007 to that in 2009?
Provide a succinct answer. 0.9. What is the ratio of the Expenses (in $) in Georgia in 2007 to that in 2009?
Provide a short and direct response. 1.41. What is the ratio of the Expenses (in $) in Afghanistan in 2007 to that in 2010?
Your answer should be very brief. 0.28. What is the ratio of the Expenses (in $) in Egypt, Arab Rep. in 2007 to that in 2010?
Give a very brief answer. 0.61. What is the ratio of the Expenses (in $) of France in 2007 to that in 2010?
Provide a succinct answer. 0.83. What is the ratio of the Expenses (in $) in Georgia in 2007 to that in 2010?
Give a very brief answer. 1.68. What is the ratio of the Expenses (in $) in Afghanistan in 2007 to that in 2011?
Ensure brevity in your answer.  0.2. What is the ratio of the Expenses (in $) of Egypt, Arab Rep. in 2007 to that in 2011?
Give a very brief answer. 0.64. What is the ratio of the Expenses (in $) in France in 2007 to that in 2011?
Offer a very short reply. 0.88. What is the ratio of the Expenses (in $) of Georgia in 2007 to that in 2011?
Your answer should be compact. 1.5. What is the ratio of the Expenses (in $) in Afghanistan in 2008 to that in 2009?
Provide a succinct answer. 0.97. What is the ratio of the Expenses (in $) in Egypt, Arab Rep. in 2008 to that in 2009?
Make the answer very short. 0.75. What is the ratio of the Expenses (in $) in France in 2008 to that in 2009?
Ensure brevity in your answer.  0.93. What is the ratio of the Expenses (in $) in Georgia in 2008 to that in 2009?
Give a very brief answer. 1.43. What is the ratio of the Expenses (in $) in Afghanistan in 2008 to that in 2010?
Give a very brief answer. 0.69. What is the ratio of the Expenses (in $) in Egypt, Arab Rep. in 2008 to that in 2010?
Offer a very short reply. 0.67. What is the ratio of the Expenses (in $) in France in 2008 to that in 2010?
Provide a succinct answer. 0.85. What is the ratio of the Expenses (in $) in Georgia in 2008 to that in 2010?
Give a very brief answer. 1.71. What is the ratio of the Expenses (in $) of Afghanistan in 2008 to that in 2011?
Keep it short and to the point. 0.49. What is the ratio of the Expenses (in $) of Egypt, Arab Rep. in 2008 to that in 2011?
Give a very brief answer. 0.71. What is the ratio of the Expenses (in $) in France in 2008 to that in 2011?
Make the answer very short. 0.91. What is the ratio of the Expenses (in $) in Georgia in 2008 to that in 2011?
Keep it short and to the point. 1.53. What is the ratio of the Expenses (in $) in Afghanistan in 2009 to that in 2010?
Give a very brief answer. 0.7. What is the ratio of the Expenses (in $) in Egypt, Arab Rep. in 2009 to that in 2010?
Your answer should be very brief. 0.89. What is the ratio of the Expenses (in $) of France in 2009 to that in 2010?
Provide a succinct answer. 0.92. What is the ratio of the Expenses (in $) in Georgia in 2009 to that in 2010?
Ensure brevity in your answer.  1.2. What is the ratio of the Expenses (in $) in Afghanistan in 2009 to that in 2011?
Your answer should be compact. 0.51. What is the ratio of the Expenses (in $) in Egypt, Arab Rep. in 2009 to that in 2011?
Your answer should be compact. 0.95. What is the ratio of the Expenses (in $) in France in 2009 to that in 2011?
Your response must be concise. 0.98. What is the ratio of the Expenses (in $) in Georgia in 2009 to that in 2011?
Make the answer very short. 1.07. What is the ratio of the Expenses (in $) in Afghanistan in 2010 to that in 2011?
Make the answer very short. 0.72. What is the ratio of the Expenses (in $) of Egypt, Arab Rep. in 2010 to that in 2011?
Ensure brevity in your answer.  1.06. What is the ratio of the Expenses (in $) in France in 2010 to that in 2011?
Make the answer very short. 1.06. What is the ratio of the Expenses (in $) of Georgia in 2010 to that in 2011?
Keep it short and to the point. 0.89. What is the difference between the highest and the second highest Expenses (in $) of Afghanistan?
Your answer should be compact. 1.07e+11. What is the difference between the highest and the second highest Expenses (in $) in Egypt, Arab Rep.?
Your answer should be very brief. 1.60e+09. What is the difference between the highest and the second highest Expenses (in $) of France?
Provide a succinct answer. 3.88e+09. What is the difference between the highest and the second highest Expenses (in $) in Georgia?
Offer a very short reply. 2.49e+07. What is the difference between the highest and the lowest Expenses (in $) of Afghanistan?
Your answer should be compact. 3.42e+11. What is the difference between the highest and the lowest Expenses (in $) of Egypt, Arab Rep.?
Offer a very short reply. 1.38e+1. What is the difference between the highest and the lowest Expenses (in $) of France?
Give a very brief answer. 1.27e+1. What is the difference between the highest and the lowest Expenses (in $) in Georgia?
Your answer should be very brief. 8.30e+08. 